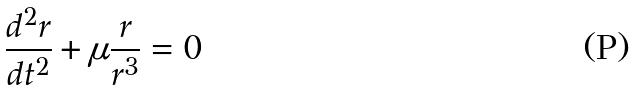<formula> <loc_0><loc_0><loc_500><loc_500>\frac { d ^ { 2 } r } { d t ^ { 2 } } + \mu \frac { r } { r ^ { 3 } } = 0</formula> 